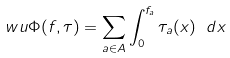<formula> <loc_0><loc_0><loc_500><loc_500>\ w u { \Phi ( f , \tau ) = \sum _ { a \in A } \int _ { 0 } ^ { f _ { a } } \tau _ { a } ( x ) \ d x }</formula> 